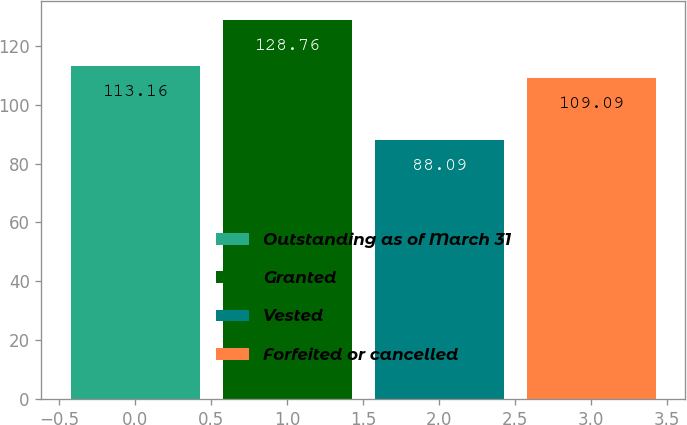Convert chart to OTSL. <chart><loc_0><loc_0><loc_500><loc_500><bar_chart><fcel>Outstanding as of March 31<fcel>Granted<fcel>Vested<fcel>Forfeited or cancelled<nl><fcel>113.16<fcel>128.76<fcel>88.09<fcel>109.09<nl></chart> 